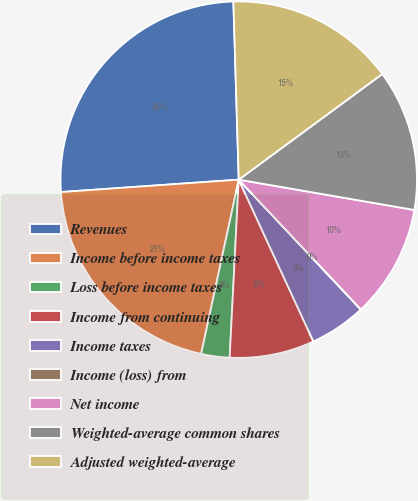Convert chart to OTSL. <chart><loc_0><loc_0><loc_500><loc_500><pie_chart><fcel>Revenues<fcel>Income before income taxes<fcel>Loss before income taxes<fcel>Income from continuing<fcel>Income taxes<fcel>Income (loss) from<fcel>Net income<fcel>Weighted-average common shares<fcel>Adjusted weighted-average<nl><fcel>25.63%<fcel>20.51%<fcel>2.57%<fcel>7.69%<fcel>5.13%<fcel>0.01%<fcel>10.26%<fcel>12.82%<fcel>15.38%<nl></chart> 